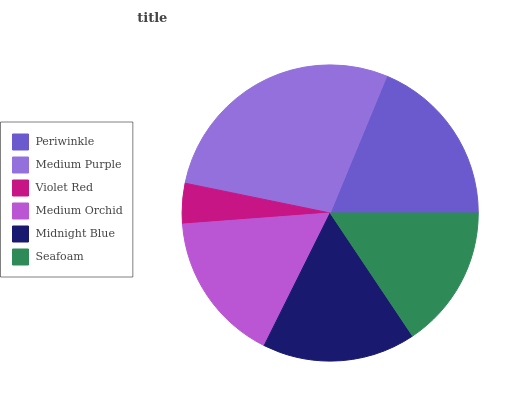Is Violet Red the minimum?
Answer yes or no. Yes. Is Medium Purple the maximum?
Answer yes or no. Yes. Is Medium Purple the minimum?
Answer yes or no. No. Is Violet Red the maximum?
Answer yes or no. No. Is Medium Purple greater than Violet Red?
Answer yes or no. Yes. Is Violet Red less than Medium Purple?
Answer yes or no. Yes. Is Violet Red greater than Medium Purple?
Answer yes or no. No. Is Medium Purple less than Violet Red?
Answer yes or no. No. Is Midnight Blue the high median?
Answer yes or no. Yes. Is Medium Orchid the low median?
Answer yes or no. Yes. Is Violet Red the high median?
Answer yes or no. No. Is Seafoam the low median?
Answer yes or no. No. 